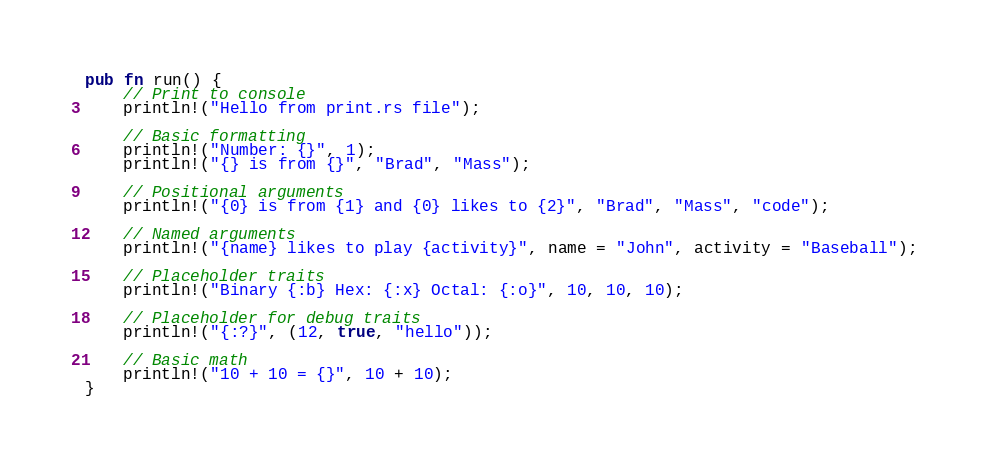<code> <loc_0><loc_0><loc_500><loc_500><_Rust_>pub fn run() {
    // Print to console
    println!("Hello from print.rs file");

    // Basic formatting
    println!("Number: {}", 1);
    println!("{} is from {}", "Brad", "Mass");

    // Positional arguments
    println!("{0} is from {1} and {0} likes to {2}", "Brad", "Mass", "code");

    // Named arguments
    println!("{name} likes to play {activity}", name = "John", activity = "Baseball");

    // Placeholder traits
    println!("Binary {:b} Hex: {:x} Octal: {:o}", 10, 10, 10);

    // Placeholder for debug traits
    println!("{:?}", (12, true, "hello"));

    // Basic math
    println!("10 + 10 = {}", 10 + 10);
}</code> 